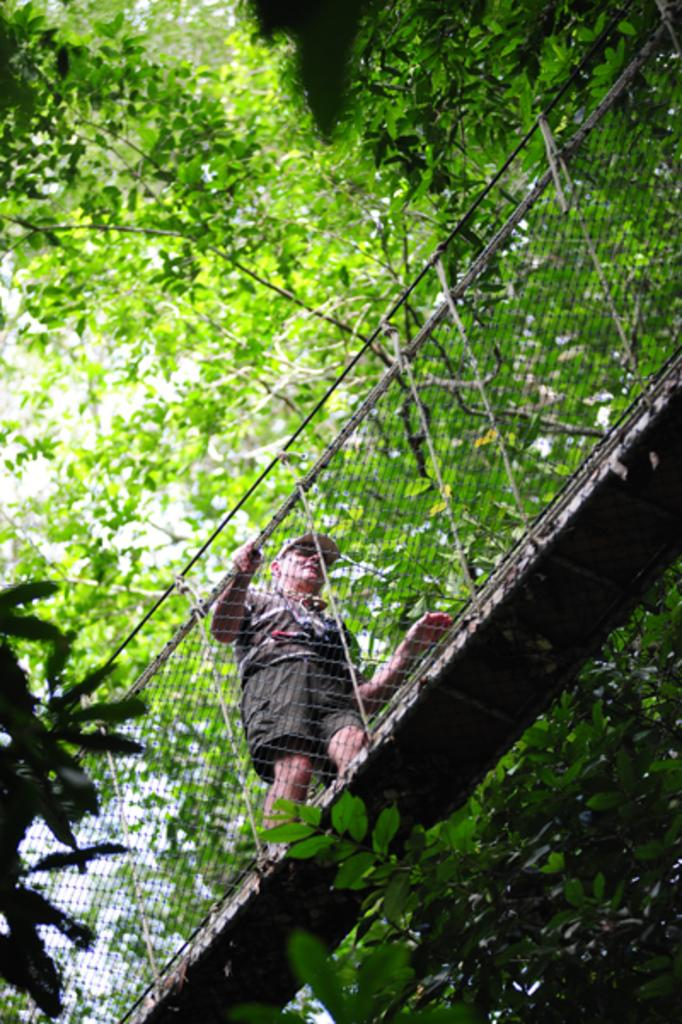Who is present in the image? There is a man in the image. What is the man doing in the image? The man is walking on a bridge. What can be seen near the bridge in the image? There is a fence in the image. What type of natural environment is visible in the image? There are trees and leaves visible in the image. What type of tramp can be seen jumping over the fence in the image? There is no tramp present in the image, and no one is jumping over the fence. What type of drawer is visible in the image? There is no drawer present in the image. 